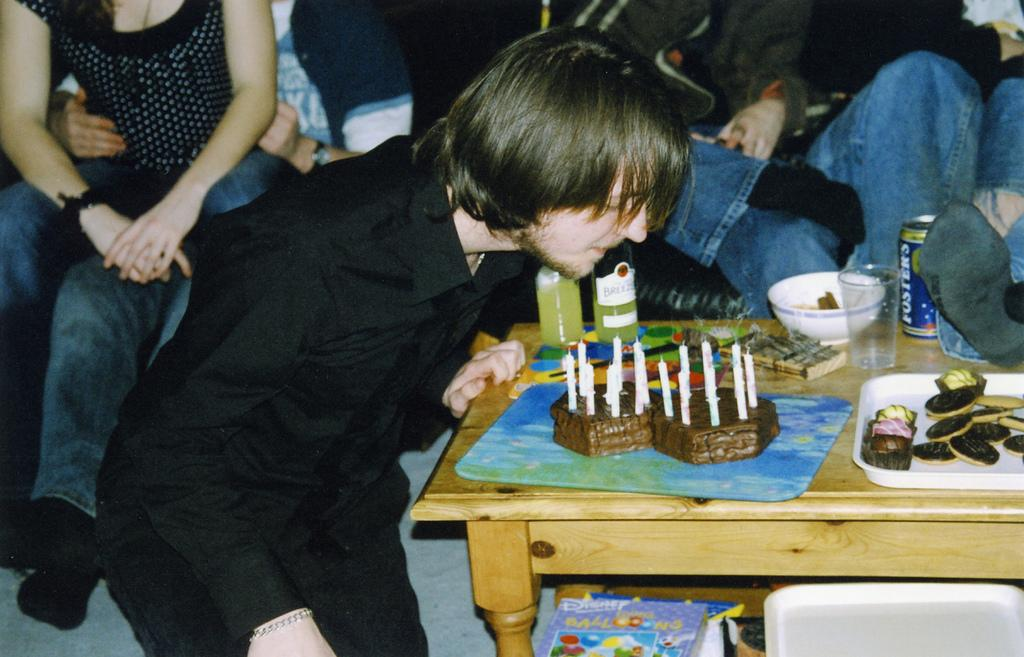Who is the main subject in the image? There is a boy in the image. What is the boy doing in the image? The boy is blowing off candles. What object is associated with the activity the boy is performing? There is a birthday cake in the image. What type of jam is the boy spreading on the snake in the image? There is no jam or snake present in the image; it features a boy blowing off candles on a birthday cake. 